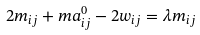<formula> <loc_0><loc_0><loc_500><loc_500>2 m _ { i j } + m a ^ { 0 } _ { i j } - 2 w _ { i j } = \lambda m _ { i j }</formula> 